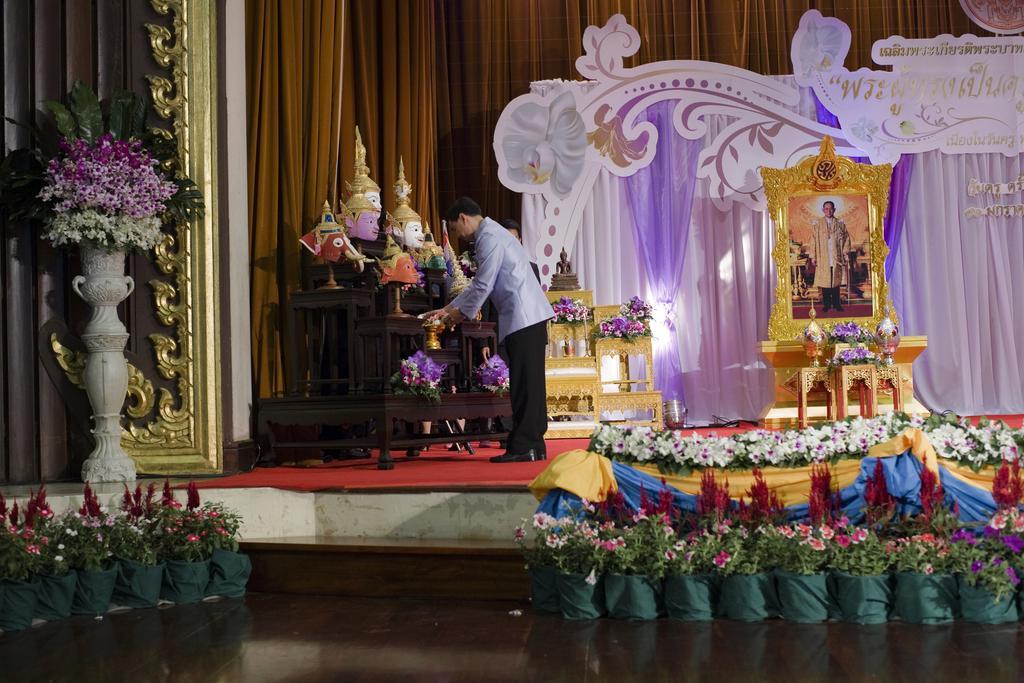Could you give a brief overview of what you see in this image? In this image I can see inner part of the building. Inside the building I can see the frame on the table. To the side there are many toys and flowers. In-front of the stage there are many flower pots and these are in white, purple and red color. To the left I can see the flower vase. In the background there is a brown color curtain can be seen. 